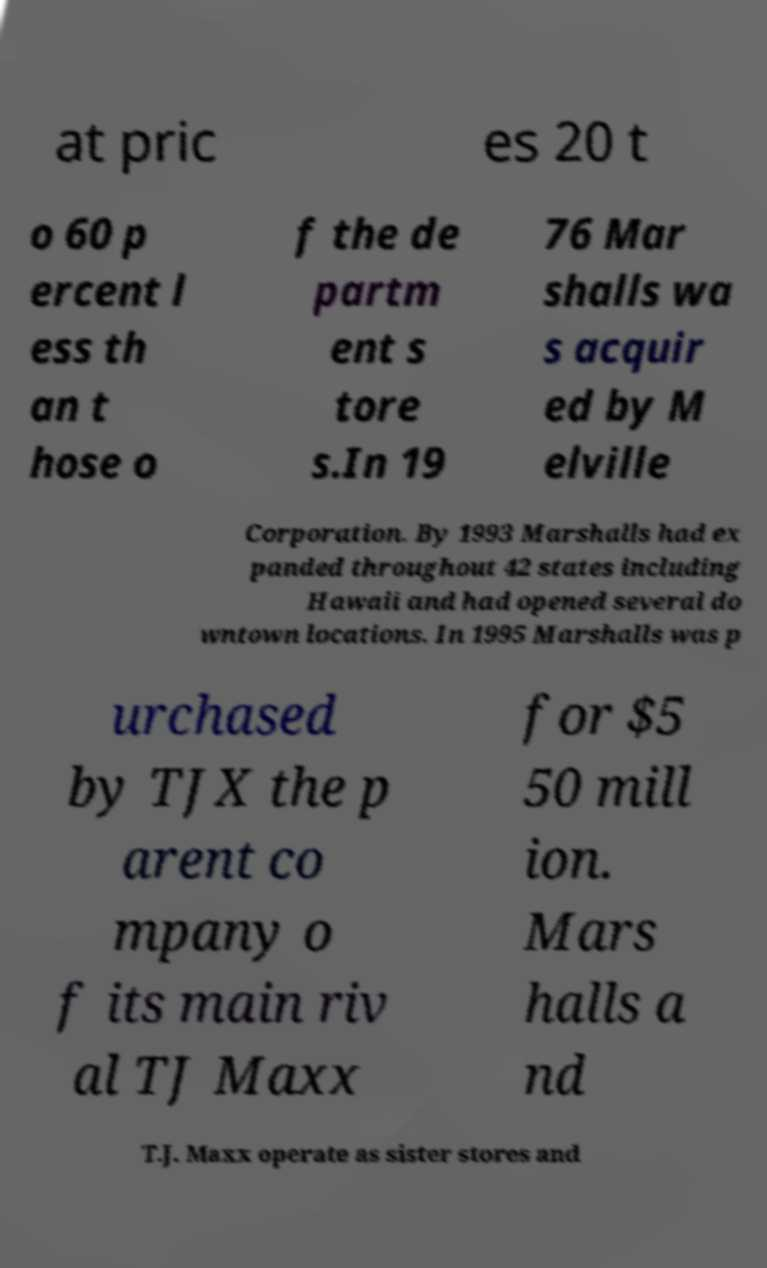Please identify and transcribe the text found in this image. at pric es 20 t o 60 p ercent l ess th an t hose o f the de partm ent s tore s.In 19 76 Mar shalls wa s acquir ed by M elville Corporation. By 1993 Marshalls had ex panded throughout 42 states including Hawaii and had opened several do wntown locations. In 1995 Marshalls was p urchased by TJX the p arent co mpany o f its main riv al TJ Maxx for $5 50 mill ion. Mars halls a nd T.J. Maxx operate as sister stores and 